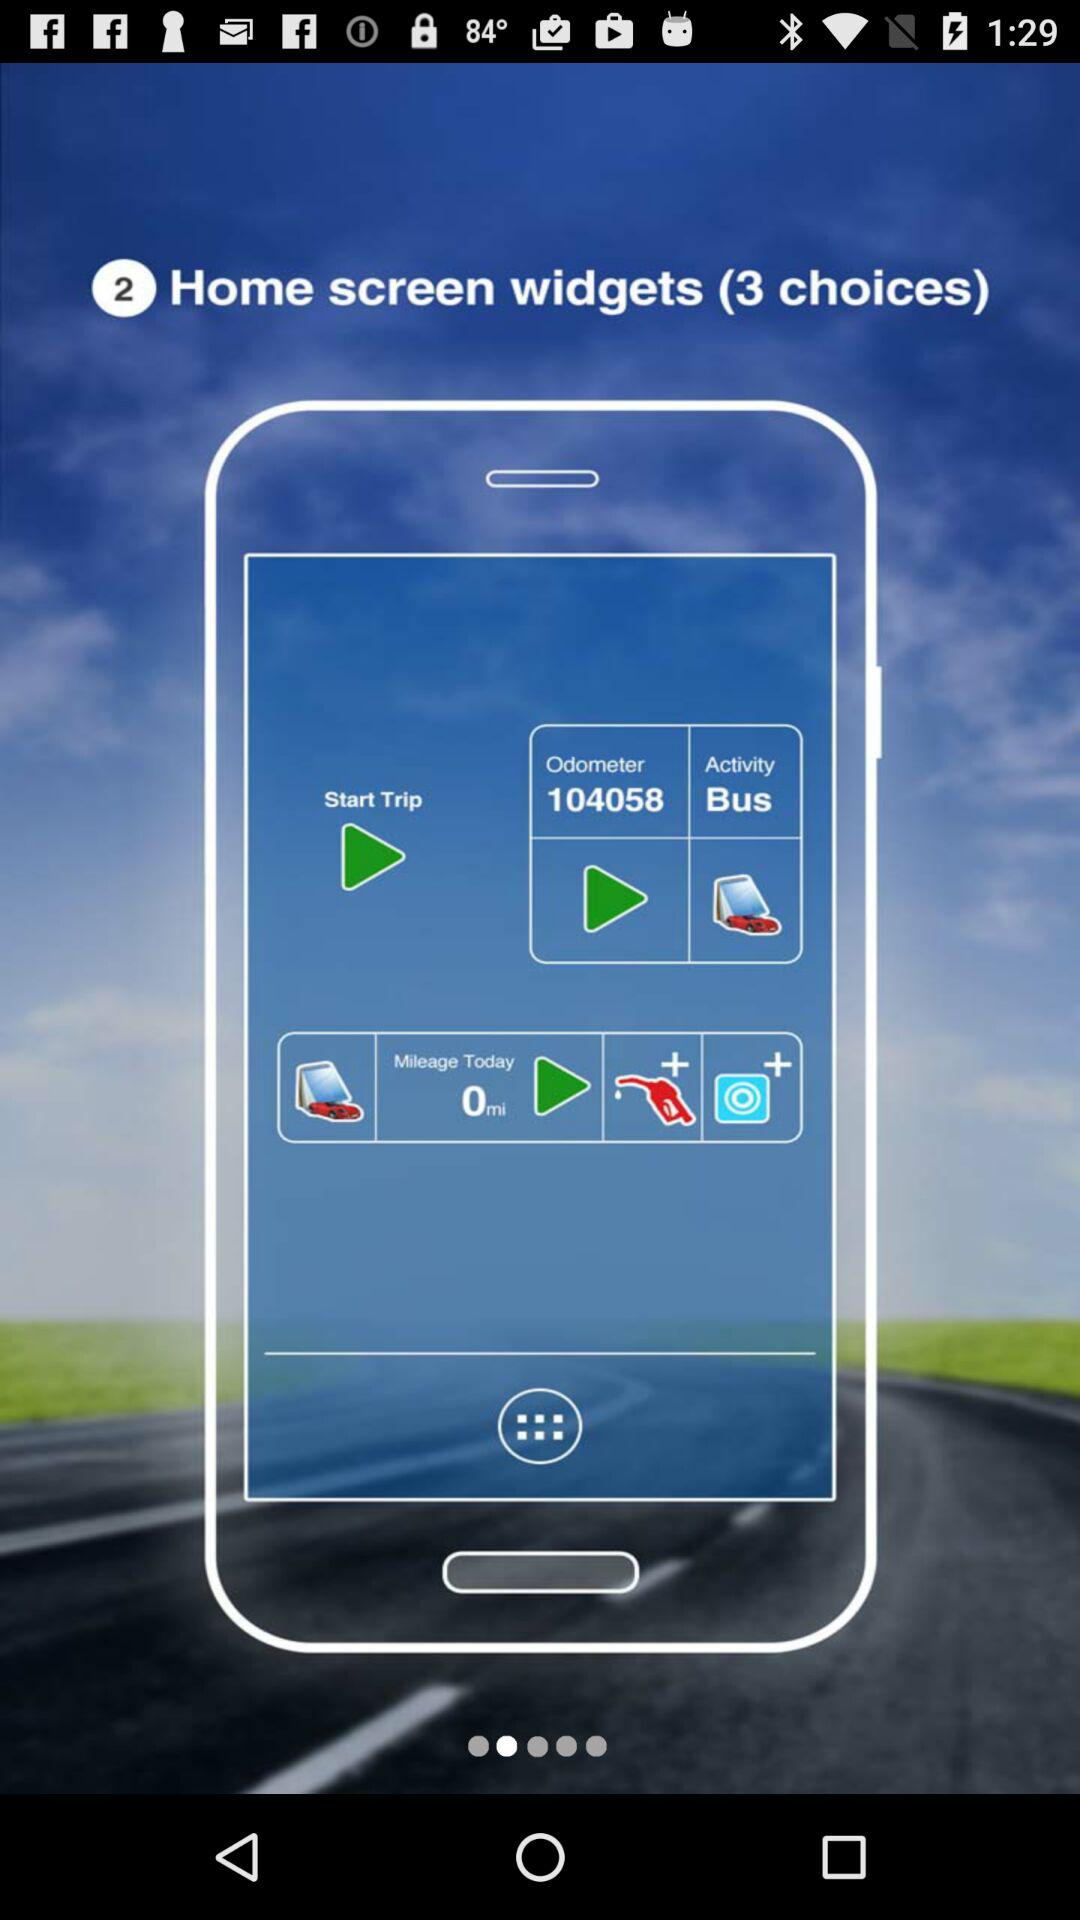How many choices are there for "Home screen widgets"? There are 3 choices. 